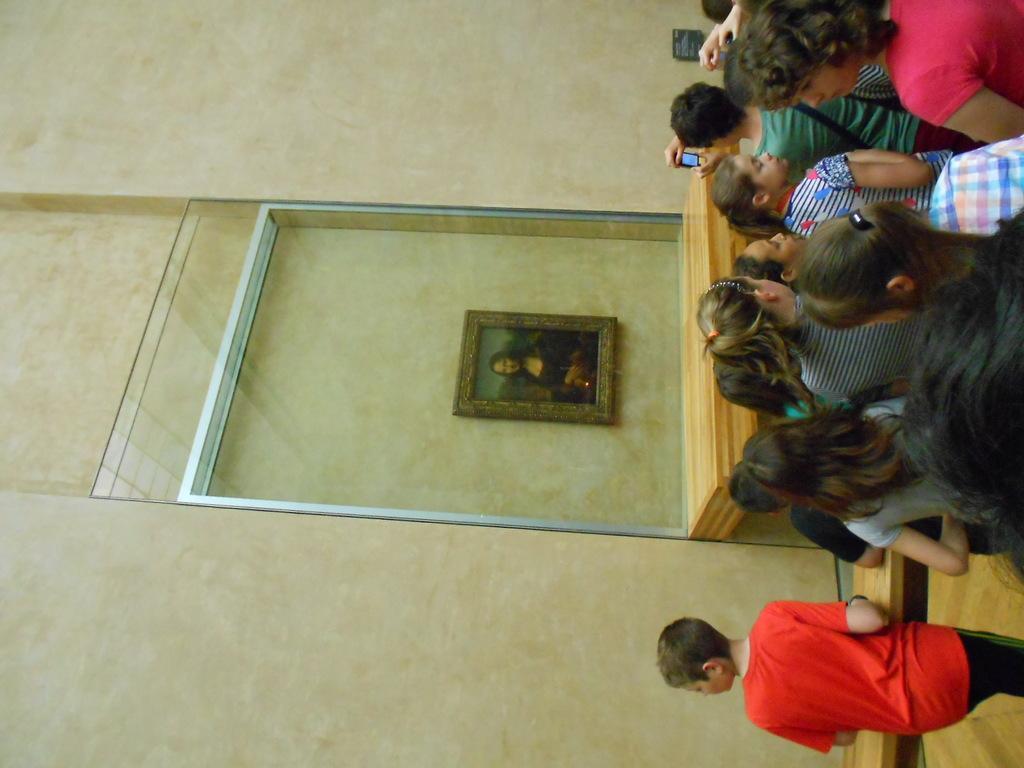Could you give a brief overview of what you see in this image? In the picture we can see some group of kids standing and some are holding mobile phones in their hands, on left side of the picture there is photo frame attached to the wall and there is glass. 